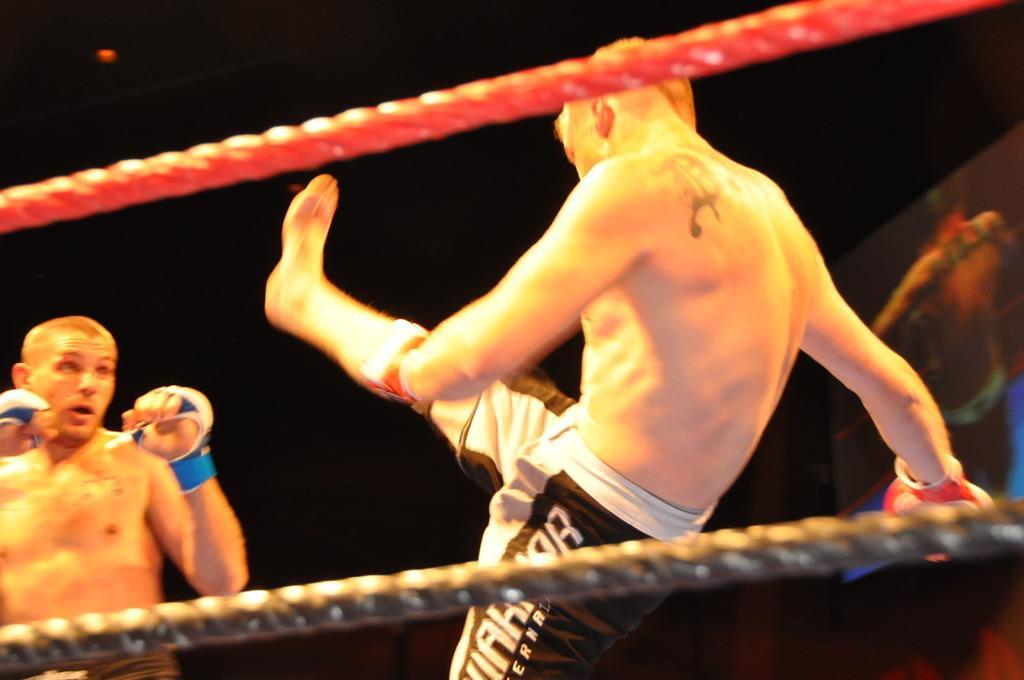In one or two sentences, can you explain what this image depicts? In this image, we can see two persons doing wrestling. There is a rope at the top and at the bottom of the image. 